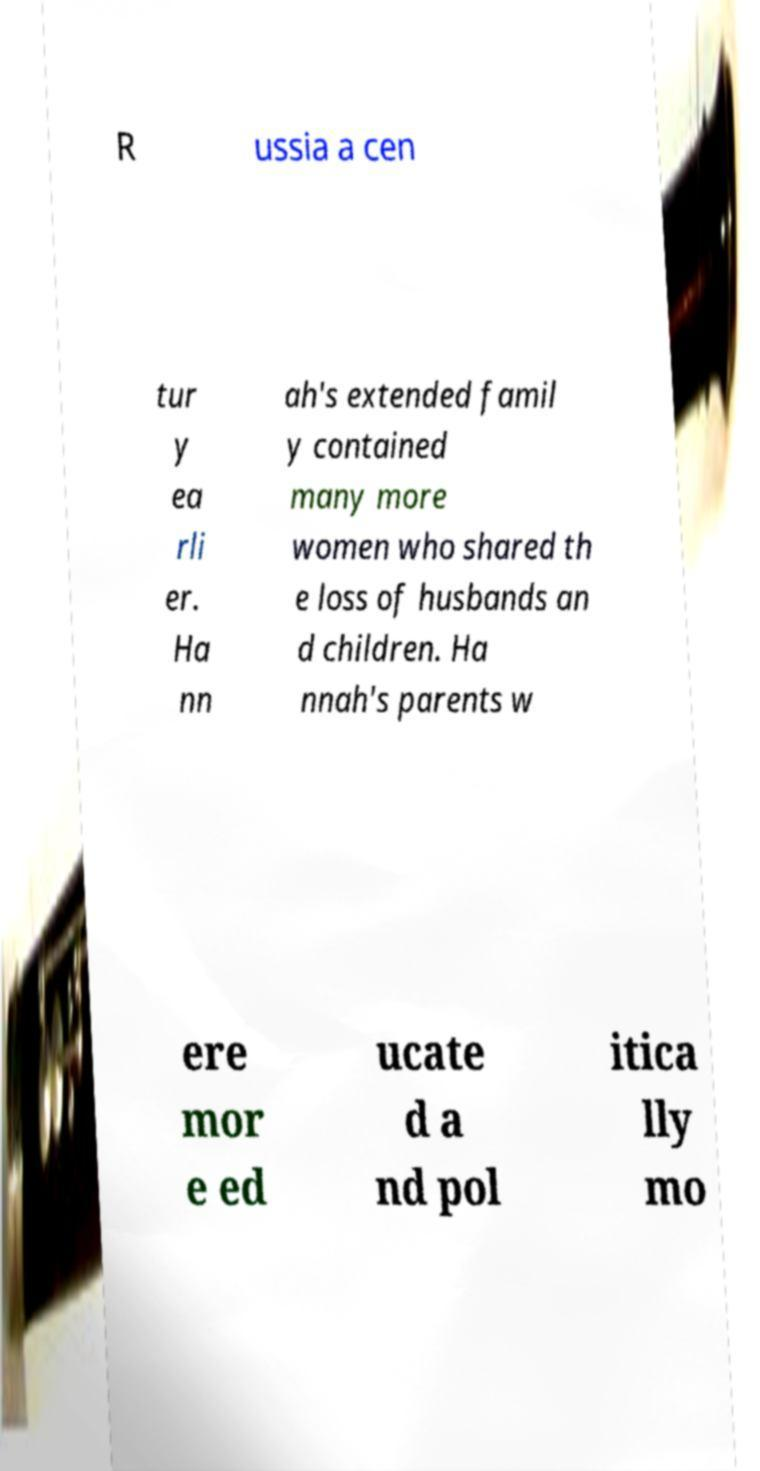Please identify and transcribe the text found in this image. R ussia a cen tur y ea rli er. Ha nn ah's extended famil y contained many more women who shared th e loss of husbands an d children. Ha nnah's parents w ere mor e ed ucate d a nd pol itica lly mo 